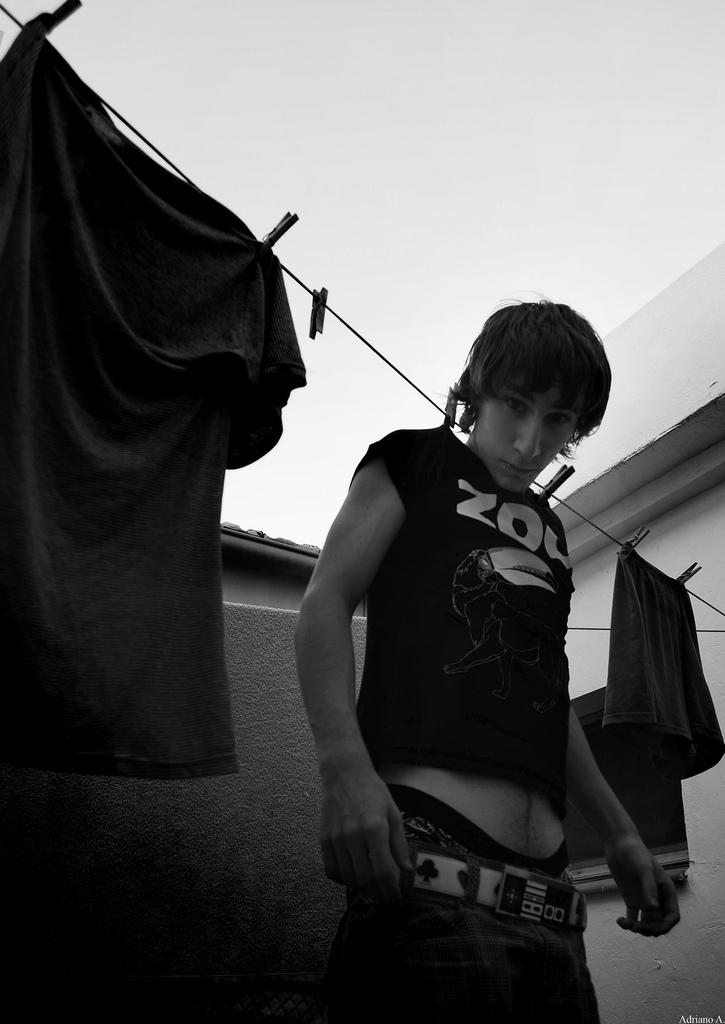What is the person in the image doing? The person is hanging on a rope in the image. What else can be seen near the person? There are clothes beside the person. What can be seen in the distance in the image? There is a house in the background of the image. What type of basketball is the person holding while hanging on the rope? There is no basketball present in the image; the person is simply hanging on a rope. 